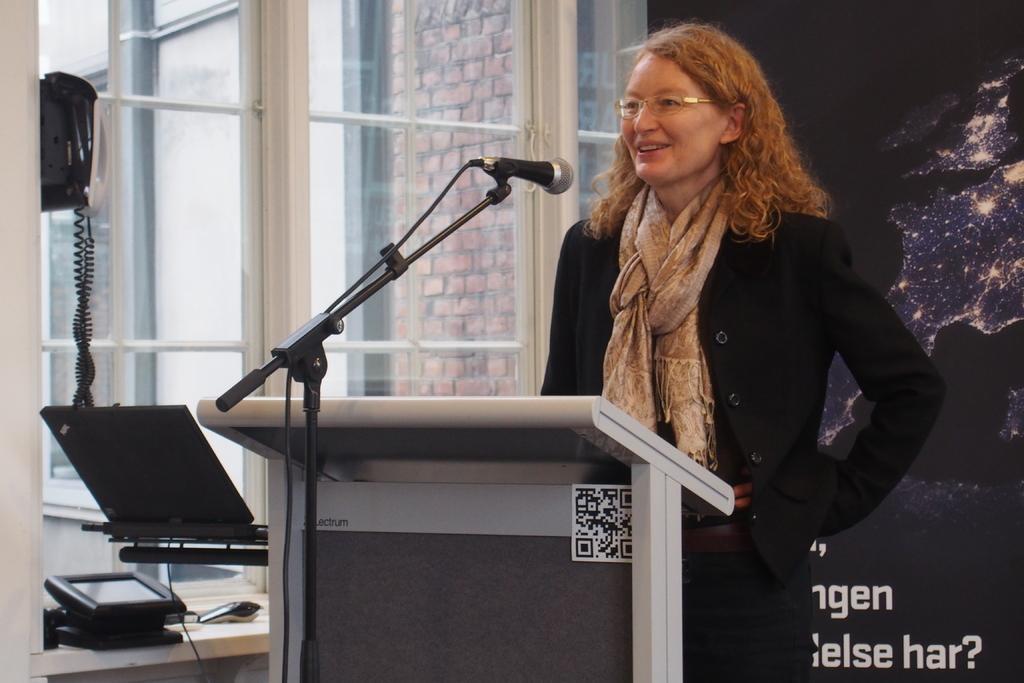Can you describe this image briefly? Here we can see a woman standing near a speech desk and speaking something in the microphone present in front of her and beside her we can see laptop and a telephone and a window present 